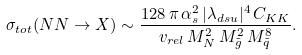Convert formula to latex. <formula><loc_0><loc_0><loc_500><loc_500>\sigma _ { t o t } ( N N \rightarrow X ) \sim \frac { 1 2 8 \, \pi \, \alpha _ { s } ^ { 2 } \, | \lambda _ { d s u } | ^ { 4 } \, C _ { K K } } { v _ { r e l } \, M _ { N } ^ { 2 } \, M _ { \tilde { g } } ^ { 2 } \, M _ { \tilde { q } } ^ { 8 } } .</formula> 